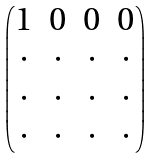<formula> <loc_0><loc_0><loc_500><loc_500>\begin{pmatrix} 1 & 0 & 0 & 0 \\ \cdot & \cdot & \cdot & \cdot \\ \cdot & \cdot & \cdot & \cdot \\ \cdot & \cdot & \cdot & \cdot \end{pmatrix}</formula> 